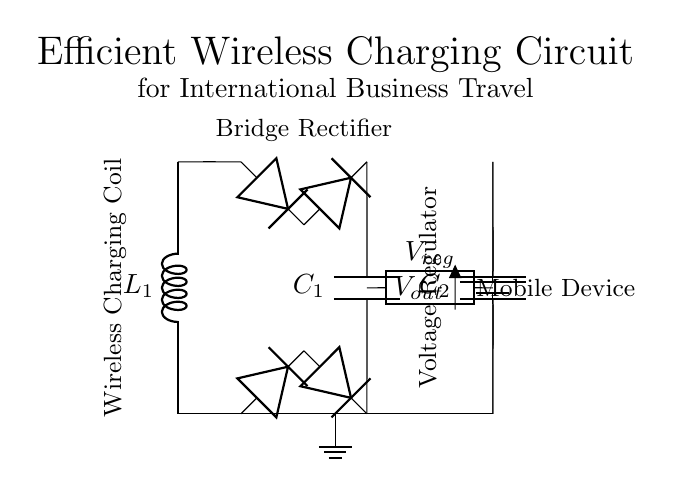What is the main component for wireless charging? The main component for wireless charging is the wireless charging coil, which is represented by the inductor labeled L1 in the circuit. It is responsible for generating a magnetic field that facilitates the wireless transfer of energy.
Answer: wireless charging coil What type of rectifier is used in this circuit? The circuit uses a bridge rectifier, which consists of four diodes arranged to convert alternating current from the coil into direct current for charging the device. The label "Bridge Rectifier" visually indicates this section of the circuit.
Answer: bridge rectifier What is the function of the capacitor labeled C1? The capacitor C1 acts as a smoothing capacitor, which filters out the voltage fluctuations from the rectified output, providing a more stable direct current to the voltage regulator.
Answer: smoothing capacitor How many diodes are in the rectifier? There are four diodes in the rectifier section of the circuit, which work together to form the bridge rectifier and rectify the AC voltage from the wireless charging coil.
Answer: four What is the output voltage of the circuit? The output voltage, labeled as Vout, is designed to provide power to the mobile device, but the voltage across it is not specified directly in the diagram. The effective output would typically align with the mobile device's operational voltage, such as five volts or a typical charging voltage.
Answer: Vout What is the role of the voltage regulator? The voltage regulator, labeled Vreg, ensures that the output voltage remains constant and within safe limits for the mobile device, even when input voltage from the rectifier may vary. It stabilizes voltage to prevent damage to sensitive electronics.
Answer: voltage regulator 